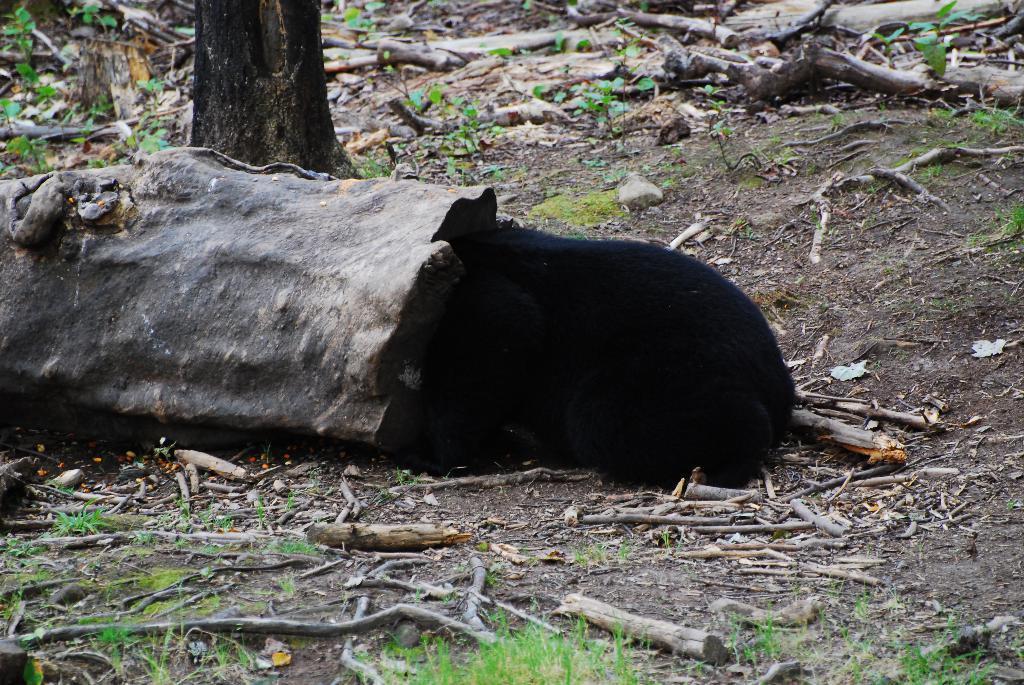Can you describe this image briefly? In this image I can see grass and number of sticks on ground. I can also see black colour thing over here. 